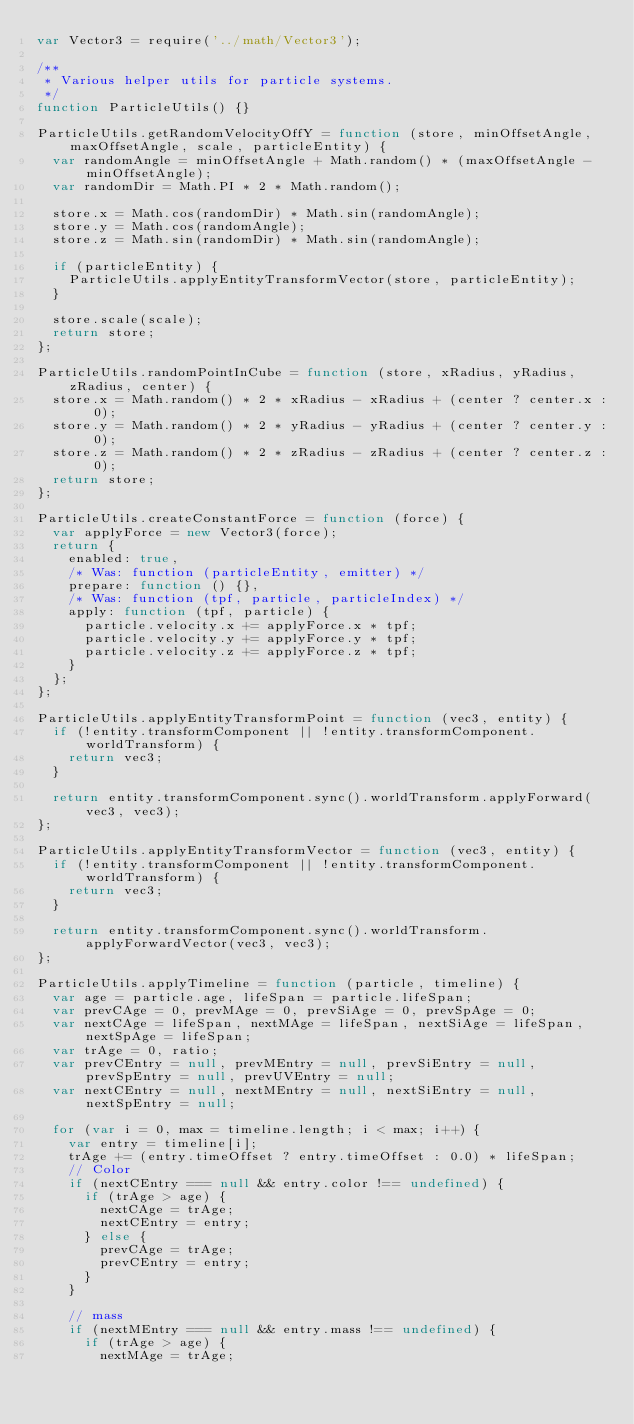<code> <loc_0><loc_0><loc_500><loc_500><_JavaScript_>var Vector3 = require('../math/Vector3');

/**
 * Various helper utils for particle systems.
 */
function ParticleUtils() {}

ParticleUtils.getRandomVelocityOffY = function (store, minOffsetAngle, maxOffsetAngle, scale, particleEntity) {
	var randomAngle = minOffsetAngle + Math.random() * (maxOffsetAngle - minOffsetAngle);
	var randomDir = Math.PI * 2 * Math.random();

	store.x = Math.cos(randomDir) * Math.sin(randomAngle);
	store.y = Math.cos(randomAngle);
	store.z = Math.sin(randomDir) * Math.sin(randomAngle);

	if (particleEntity) {
		ParticleUtils.applyEntityTransformVector(store, particleEntity);
	}

	store.scale(scale);
	return store;
};

ParticleUtils.randomPointInCube = function (store, xRadius, yRadius, zRadius, center) {
	store.x = Math.random() * 2 * xRadius - xRadius + (center ? center.x : 0);
	store.y = Math.random() * 2 * yRadius - yRadius + (center ? center.y : 0);
	store.z = Math.random() * 2 * zRadius - zRadius + (center ? center.z : 0);
	return store;
};

ParticleUtils.createConstantForce = function (force) {
	var applyForce = new Vector3(force);
	return {
		enabled: true,
		/* Was: function (particleEntity, emitter) */
		prepare: function () {},
		/* Was: function (tpf, particle, particleIndex) */
		apply: function (tpf, particle) {
			particle.velocity.x += applyForce.x * tpf;
			particle.velocity.y += applyForce.y * tpf;
			particle.velocity.z += applyForce.z * tpf;
		}
	};
};

ParticleUtils.applyEntityTransformPoint = function (vec3, entity) {
	if (!entity.transformComponent || !entity.transformComponent.worldTransform) {
		return vec3;
	}

	return entity.transformComponent.sync().worldTransform.applyForward(vec3, vec3);
};

ParticleUtils.applyEntityTransformVector = function (vec3, entity) {
	if (!entity.transformComponent || !entity.transformComponent.worldTransform) {
		return vec3;
	}

	return entity.transformComponent.sync().worldTransform.applyForwardVector(vec3, vec3);
};

ParticleUtils.applyTimeline = function (particle, timeline) {
	var age = particle.age, lifeSpan = particle.lifeSpan;
	var prevCAge = 0, prevMAge = 0, prevSiAge = 0, prevSpAge = 0;
	var nextCAge = lifeSpan, nextMAge = lifeSpan, nextSiAge = lifeSpan, nextSpAge = lifeSpan;
	var trAge = 0, ratio;
	var prevCEntry = null, prevMEntry = null, prevSiEntry = null, prevSpEntry = null, prevUVEntry = null;
	var nextCEntry = null, nextMEntry = null, nextSiEntry = null, nextSpEntry = null;

	for (var i = 0, max = timeline.length; i < max; i++) {
		var entry = timeline[i];
		trAge += (entry.timeOffset ? entry.timeOffset : 0.0) * lifeSpan;
		// Color
		if (nextCEntry === null && entry.color !== undefined) {
			if (trAge > age) {
				nextCAge = trAge;
				nextCEntry = entry;
			} else {
				prevCAge = trAge;
				prevCEntry = entry;
			}
		}

		// mass
		if (nextMEntry === null && entry.mass !== undefined) {
			if (trAge > age) {
				nextMAge = trAge;</code> 